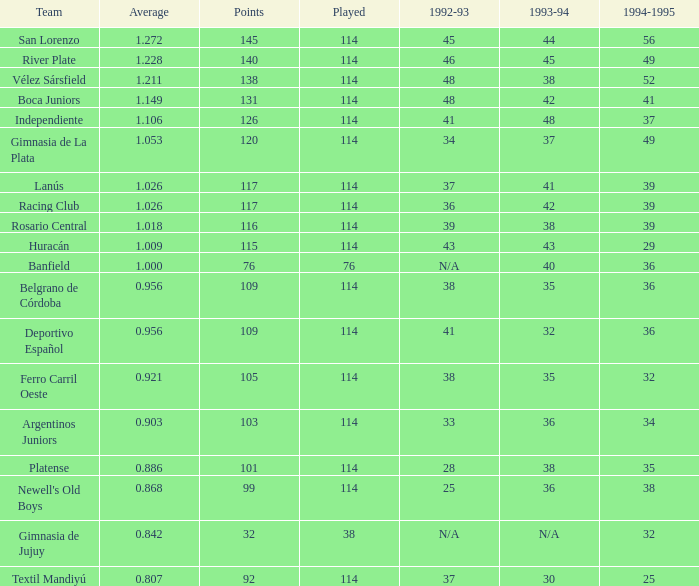Name the most played 114.0. 